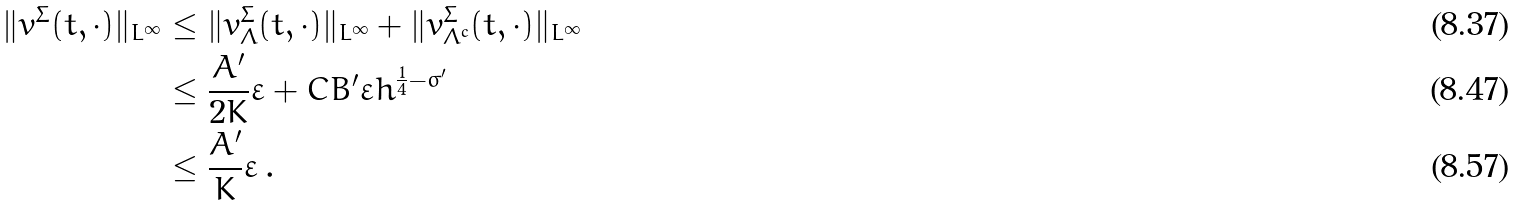<formula> <loc_0><loc_0><loc_500><loc_500>\| v ^ { \Sigma } ( t , \cdot ) \| _ { L ^ { \infty } } & \leq \| v ^ { \Sigma } _ { \Lambda } ( t , \cdot ) \| _ { L ^ { \infty } } + \| v ^ { \Sigma } _ { \Lambda ^ { c } } ( t , \cdot ) \| _ { L ^ { \infty } } \\ & \leq \frac { A ^ { \prime } } { 2 K } \varepsilon + C B ^ { \prime } \varepsilon h ^ { \frac { 1 } { 4 } - \sigma ^ { \prime } } \\ & \leq \frac { A ^ { \prime } } { K } \varepsilon \, .</formula> 